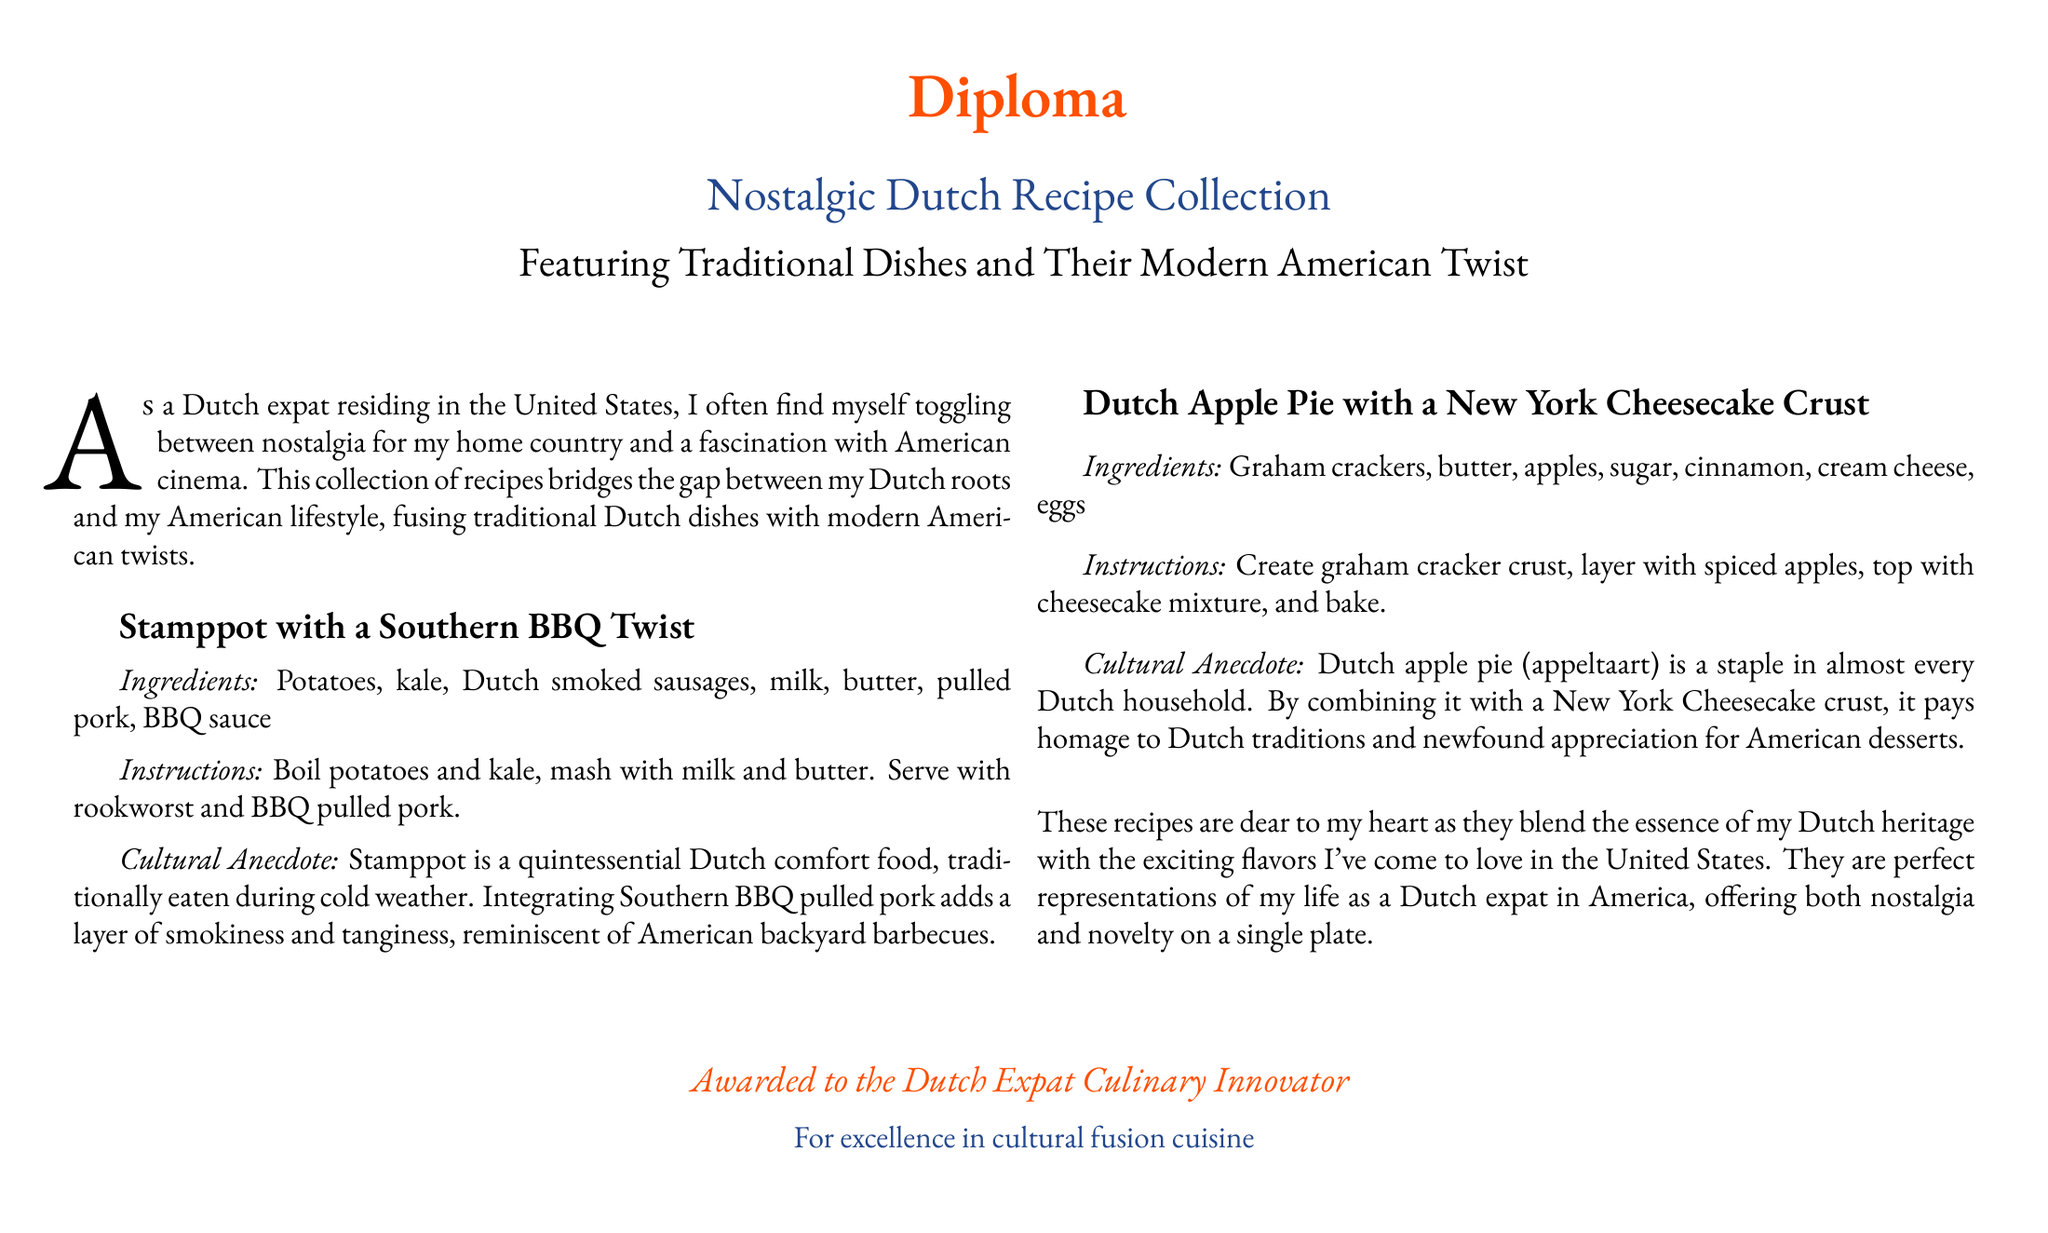What is the title of the document? The title is prominently displayed at the top of the document, introducing the main topic.
Answer: Nostalgic Dutch Recipe Collection Who is awarded the diploma? The diploma notes the recipient is recognized for their culinary innovation in cultural fusion, specifically as a Dutch expat.
Answer: Dutch Expat Culinary Innovator What dish combines apples with a cheesecake? The recipe section outlines this merging of flavors through a specific traditional dessert with an American twist.
Answer: Dutch Apple Pie with a New York Cheesecake Crust What type of food is Stamppot? Stamppot is classified within the text as a comforting food typically enjoyed during specific weather conditions.
Answer: Comfort food How many recipes are featured in the collection? The document explicitly lists and displays two diverse recipes that represent the culinary blend being celebrated.
Answer: Two What key ingredient is used in the first recipe? The initial recipe features a staple ingredient common to both Dutch and American cuisines.
Answer: Potatoes What cooking method is used for the potatoes in the first recipe? The document provides detailed steps, including a specific method for preparing this traditional ingredient.
Answer: Boil What cultural aspect does the document highlight? The document emphasizes a specific theme combining heritage and contemporary influences in a culinary context.
Answer: Cultural fusion cuisine 